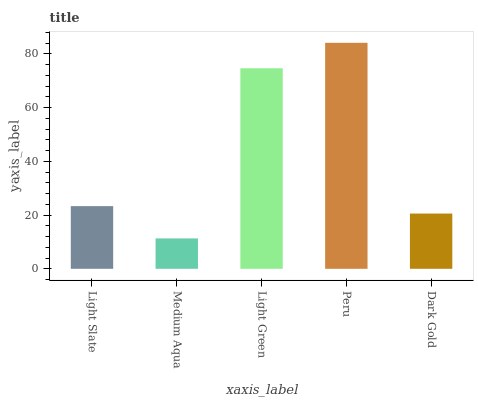Is Medium Aqua the minimum?
Answer yes or no. Yes. Is Peru the maximum?
Answer yes or no. Yes. Is Light Green the minimum?
Answer yes or no. No. Is Light Green the maximum?
Answer yes or no. No. Is Light Green greater than Medium Aqua?
Answer yes or no. Yes. Is Medium Aqua less than Light Green?
Answer yes or no. Yes. Is Medium Aqua greater than Light Green?
Answer yes or no. No. Is Light Green less than Medium Aqua?
Answer yes or no. No. Is Light Slate the high median?
Answer yes or no. Yes. Is Light Slate the low median?
Answer yes or no. Yes. Is Dark Gold the high median?
Answer yes or no. No. Is Peru the low median?
Answer yes or no. No. 